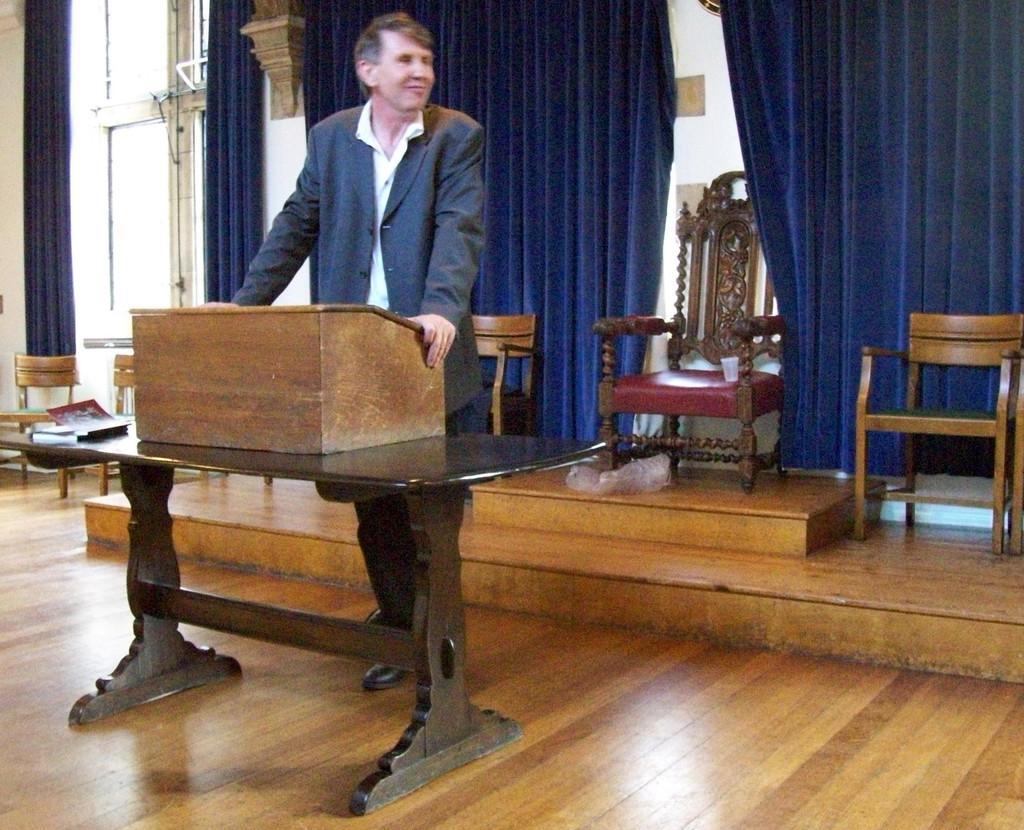What is the man in the image doing? The man is standing in the image. What is the man holding in the image? The man is holding a wooden box. What furniture can be seen in the image? There is a table and a chair in the image. What type of curtain is present in the image? There is a blue curtain in the image. What is the floor made of in the image? The floor is made of wood. What type of cabbage is the man eating in the image? There is no cabbage present in the image, and the man is not eating anything. 